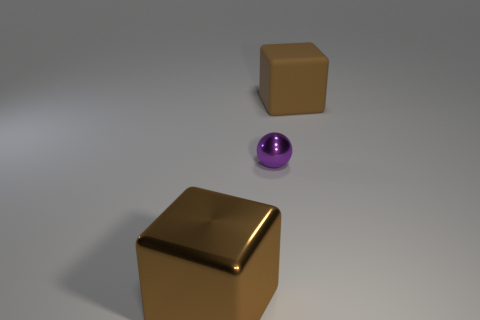What material is the ball?
Ensure brevity in your answer.  Metal. Does the brown matte cube have the same size as the metallic block?
Ensure brevity in your answer.  Yes. What number of blocks are either cyan rubber things or big shiny objects?
Keep it short and to the point. 1. The large cube in front of the brown object to the right of the small purple metal ball is what color?
Your response must be concise. Brown. Is the number of small purple objects that are in front of the big shiny cube less than the number of big brown objects in front of the small purple metal ball?
Make the answer very short. Yes. There is a ball; does it have the same size as the brown object in front of the tiny purple metal sphere?
Offer a terse response. No. The thing that is both on the right side of the large brown metallic cube and in front of the matte object has what shape?
Provide a short and direct response. Sphere. There is a large object on the left side of the rubber block; what number of large rubber blocks are in front of it?
Your response must be concise. 0. Do the cube behind the purple thing and the tiny object have the same material?
Make the answer very short. No. What is the size of the brown thing that is right of the large thing in front of the large rubber cube?
Offer a very short reply. Large. 